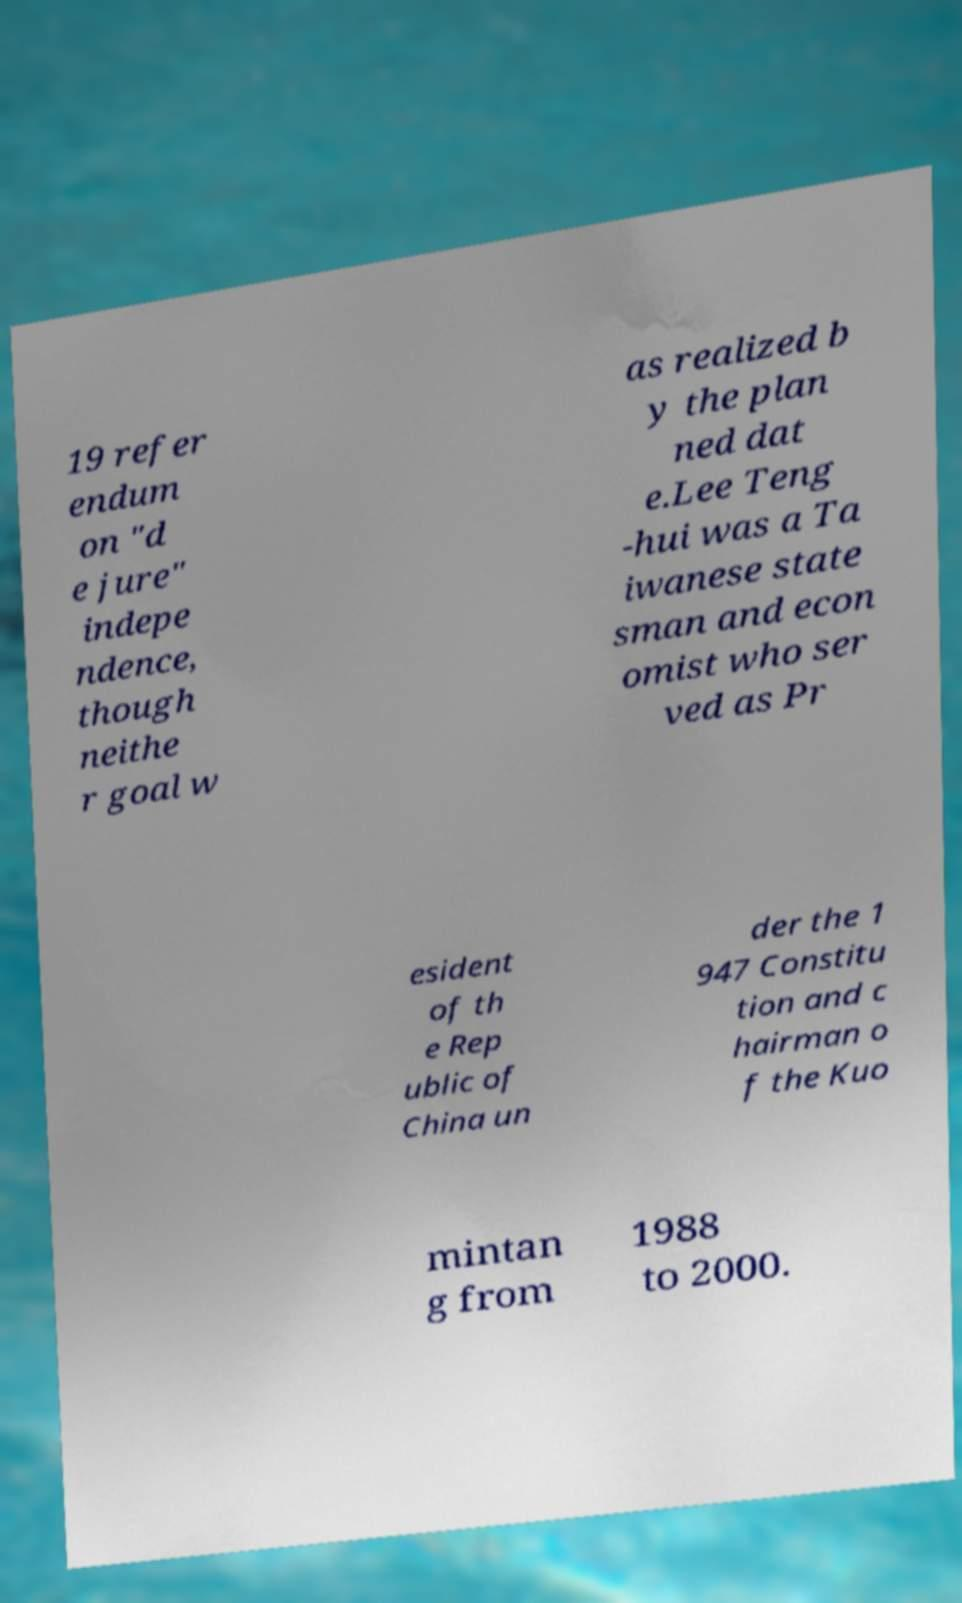Can you accurately transcribe the text from the provided image for me? 19 refer endum on "d e jure" indepe ndence, though neithe r goal w as realized b y the plan ned dat e.Lee Teng -hui was a Ta iwanese state sman and econ omist who ser ved as Pr esident of th e Rep ublic of China un der the 1 947 Constitu tion and c hairman o f the Kuo mintan g from 1988 to 2000. 